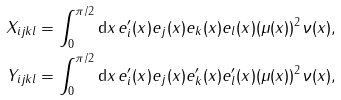Convert formula to latex. <formula><loc_0><loc_0><loc_500><loc_500>X _ { i j k l } & = \int _ { 0 } ^ { \pi / 2 } \text {d} x \, e ^ { \prime } _ { i } ( x ) e _ { j } ( x ) e _ { k } ( x ) e _ { l } ( x ) ( \mu ( x ) ) ^ { 2 } \nu ( x ) , \\ Y _ { i j k l } & = \int _ { 0 } ^ { \pi / 2 } \text {d} x \, e ^ { \prime } _ { i } ( x ) e _ { j } ( x ) e ^ { \prime } _ { k } ( x ) e ^ { \prime } _ { l } ( x ) ( \mu ( x ) ) ^ { 2 } \nu ( x ) ,</formula> 